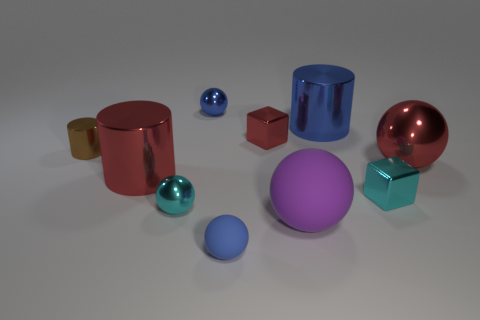There is another object that is the same shape as the tiny red thing; what is its size? The object sharing the same spherical shape as the tiny red thing is the large pink sphere. Comparing sizes, the pink sphere is significantly larger than the tiny red sphere. 